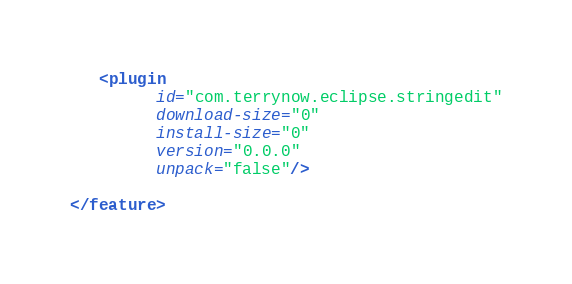Convert code to text. <code><loc_0><loc_0><loc_500><loc_500><_XML_>   <plugin
         id="com.terrynow.eclipse.stringedit"
         download-size="0"
         install-size="0"
         version="0.0.0"
         unpack="false"/>

</feature>
</code> 